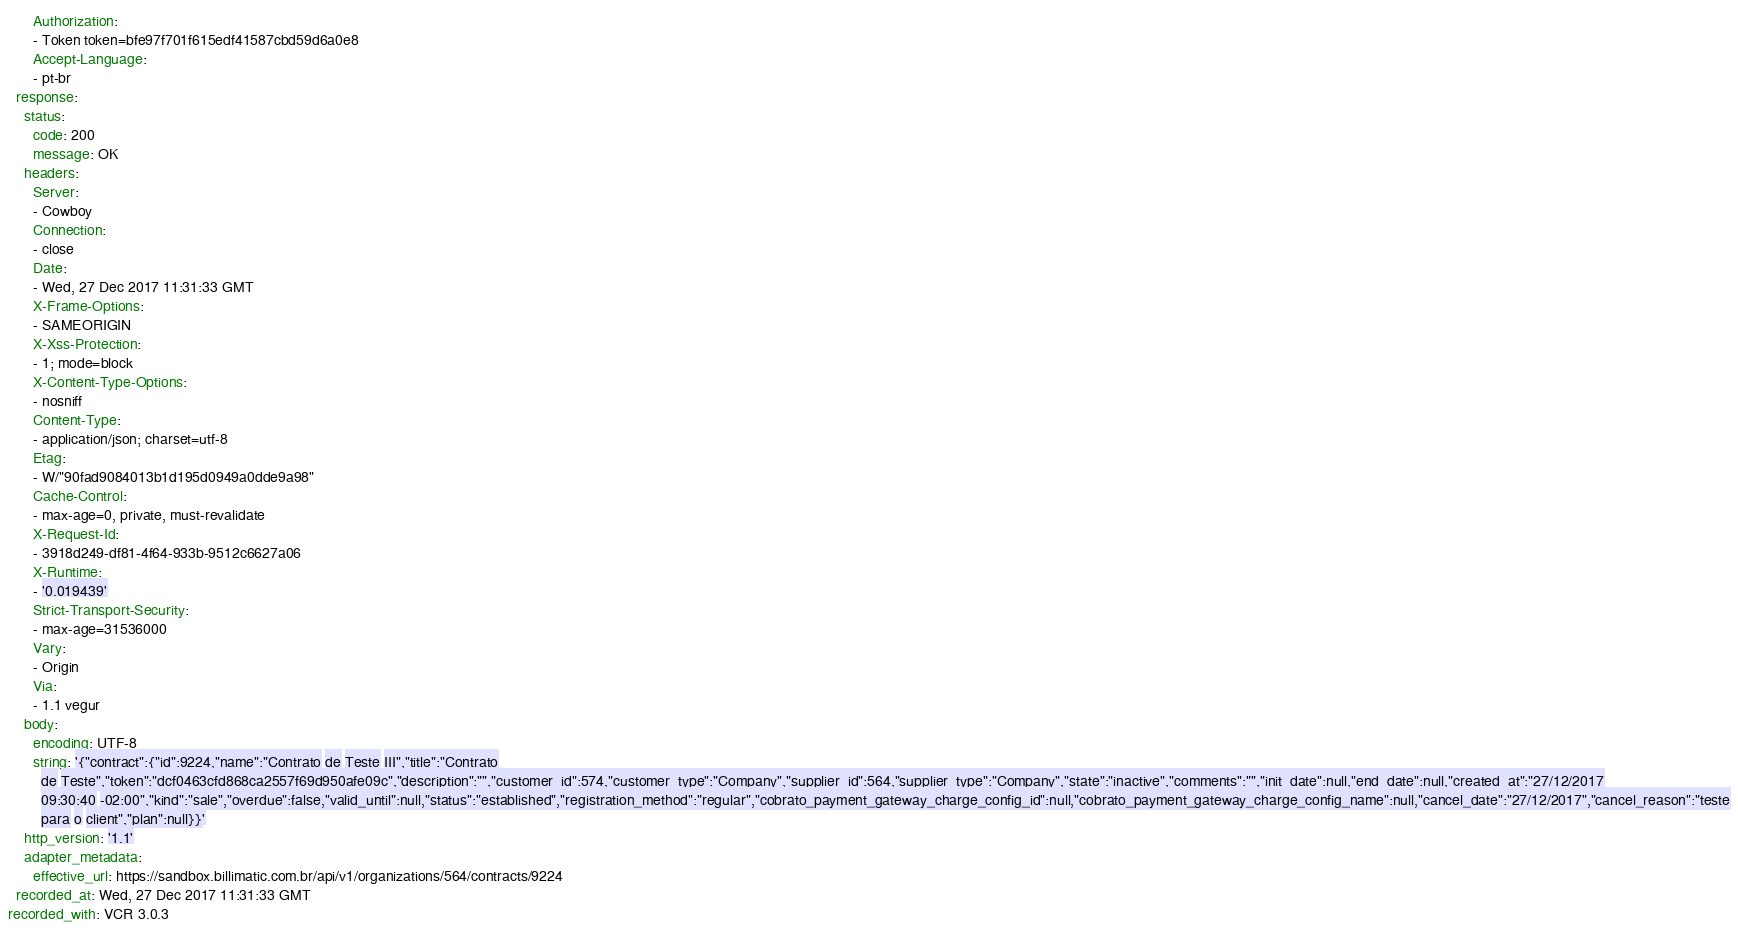Convert code to text. <code><loc_0><loc_0><loc_500><loc_500><_YAML_>      Authorization:
      - Token token=bfe97f701f615edf41587cbd59d6a0e8
      Accept-Language:
      - pt-br
  response:
    status:
      code: 200
      message: OK
    headers:
      Server:
      - Cowboy
      Connection:
      - close
      Date:
      - Wed, 27 Dec 2017 11:31:33 GMT
      X-Frame-Options:
      - SAMEORIGIN
      X-Xss-Protection:
      - 1; mode=block
      X-Content-Type-Options:
      - nosniff
      Content-Type:
      - application/json; charset=utf-8
      Etag:
      - W/"90fad9084013b1d195d0949a0dde9a98"
      Cache-Control:
      - max-age=0, private, must-revalidate
      X-Request-Id:
      - 3918d249-df81-4f64-933b-9512c6627a06
      X-Runtime:
      - '0.019439'
      Strict-Transport-Security:
      - max-age=31536000
      Vary:
      - Origin
      Via:
      - 1.1 vegur
    body:
      encoding: UTF-8
      string: '{"contract":{"id":9224,"name":"Contrato de Teste III","title":"Contrato
        de Teste","token":"dcf0463cfd868ca2557f69d950afe09c","description":"","customer_id":574,"customer_type":"Company","supplier_id":564,"supplier_type":"Company","state":"inactive","comments":"","init_date":null,"end_date":null,"created_at":"27/12/2017
        09:30:40 -02:00","kind":"sale","overdue":false,"valid_until":null,"status":"established","registration_method":"regular","cobrato_payment_gateway_charge_config_id":null,"cobrato_payment_gateway_charge_config_name":null,"cancel_date":"27/12/2017","cancel_reason":"teste
        para o client","plan":null}}'
    http_version: '1.1'
    adapter_metadata:
      effective_url: https://sandbox.billimatic.com.br/api/v1/organizations/564/contracts/9224
  recorded_at: Wed, 27 Dec 2017 11:31:33 GMT
recorded_with: VCR 3.0.3
</code> 